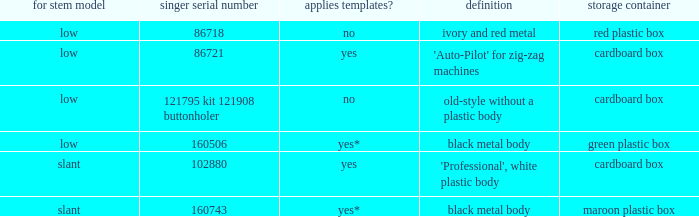What's the shank type of the buttonholer with red plastic box as storage case? Low. 